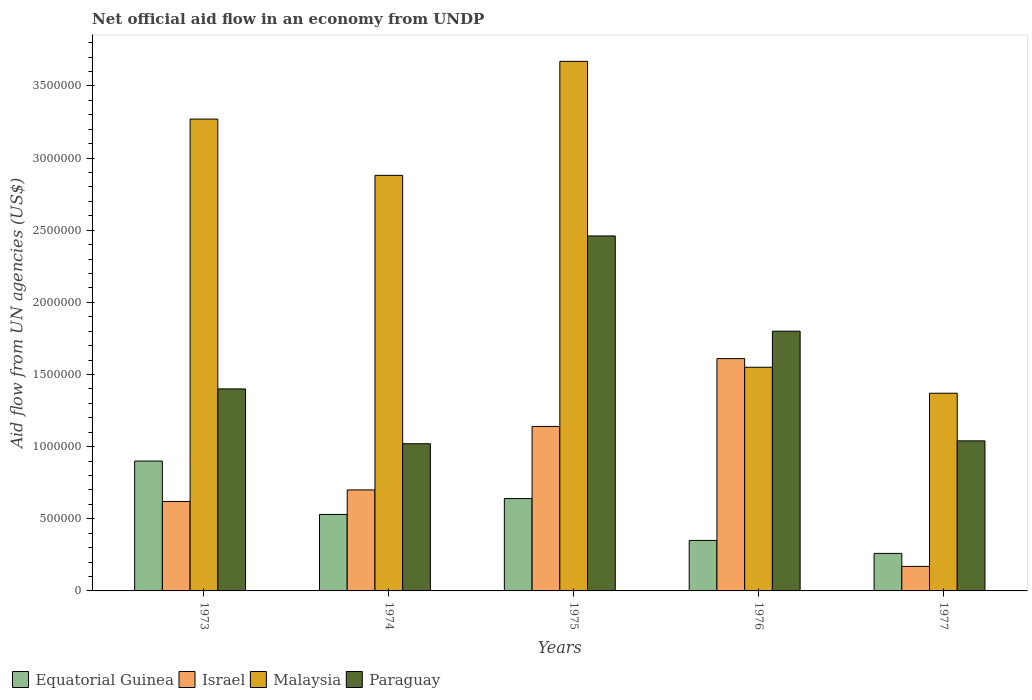How many different coloured bars are there?
Your answer should be very brief. 4. Are the number of bars on each tick of the X-axis equal?
Your answer should be compact. Yes. How many bars are there on the 2nd tick from the left?
Keep it short and to the point. 4. What is the label of the 4th group of bars from the left?
Your answer should be very brief. 1976. In how many cases, is the number of bars for a given year not equal to the number of legend labels?
Your answer should be compact. 0. What is the net official aid flow in Israel in 1976?
Ensure brevity in your answer.  1.61e+06. Across all years, what is the maximum net official aid flow in Israel?
Provide a succinct answer. 1.61e+06. Across all years, what is the minimum net official aid flow in Malaysia?
Your response must be concise. 1.37e+06. In which year was the net official aid flow in Israel maximum?
Give a very brief answer. 1976. In which year was the net official aid flow in Paraguay minimum?
Your response must be concise. 1974. What is the total net official aid flow in Equatorial Guinea in the graph?
Offer a terse response. 2.68e+06. What is the difference between the net official aid flow in Israel in 1977 and the net official aid flow in Malaysia in 1974?
Make the answer very short. -2.71e+06. What is the average net official aid flow in Malaysia per year?
Provide a succinct answer. 2.55e+06. What is the ratio of the net official aid flow in Paraguay in 1974 to that in 1976?
Your answer should be compact. 0.57. Is the difference between the net official aid flow in Israel in 1976 and 1977 greater than the difference between the net official aid flow in Equatorial Guinea in 1976 and 1977?
Make the answer very short. Yes. What is the difference between the highest and the second highest net official aid flow in Paraguay?
Give a very brief answer. 6.60e+05. What is the difference between the highest and the lowest net official aid flow in Malaysia?
Provide a succinct answer. 2.30e+06. In how many years, is the net official aid flow in Paraguay greater than the average net official aid flow in Paraguay taken over all years?
Ensure brevity in your answer.  2. Is the sum of the net official aid flow in Israel in 1975 and 1976 greater than the maximum net official aid flow in Equatorial Guinea across all years?
Your answer should be very brief. Yes. Is it the case that in every year, the sum of the net official aid flow in Israel and net official aid flow in Equatorial Guinea is greater than the sum of net official aid flow in Malaysia and net official aid flow in Paraguay?
Offer a very short reply. No. What does the 1st bar from the left in 1977 represents?
Offer a very short reply. Equatorial Guinea. What does the 1st bar from the right in 1973 represents?
Give a very brief answer. Paraguay. How many bars are there?
Give a very brief answer. 20. Are all the bars in the graph horizontal?
Keep it short and to the point. No. How many years are there in the graph?
Ensure brevity in your answer.  5. Are the values on the major ticks of Y-axis written in scientific E-notation?
Ensure brevity in your answer.  No. Does the graph contain any zero values?
Your answer should be compact. No. How many legend labels are there?
Provide a short and direct response. 4. What is the title of the graph?
Give a very brief answer. Net official aid flow in an economy from UNDP. Does "Turkey" appear as one of the legend labels in the graph?
Ensure brevity in your answer.  No. What is the label or title of the Y-axis?
Provide a succinct answer. Aid flow from UN agencies (US$). What is the Aid flow from UN agencies (US$) of Equatorial Guinea in 1973?
Give a very brief answer. 9.00e+05. What is the Aid flow from UN agencies (US$) in Israel in 1973?
Your response must be concise. 6.20e+05. What is the Aid flow from UN agencies (US$) in Malaysia in 1973?
Offer a very short reply. 3.27e+06. What is the Aid flow from UN agencies (US$) in Paraguay in 1973?
Keep it short and to the point. 1.40e+06. What is the Aid flow from UN agencies (US$) of Equatorial Guinea in 1974?
Ensure brevity in your answer.  5.30e+05. What is the Aid flow from UN agencies (US$) of Malaysia in 1974?
Offer a terse response. 2.88e+06. What is the Aid flow from UN agencies (US$) in Paraguay in 1974?
Your answer should be very brief. 1.02e+06. What is the Aid flow from UN agencies (US$) in Equatorial Guinea in 1975?
Make the answer very short. 6.40e+05. What is the Aid flow from UN agencies (US$) of Israel in 1975?
Your response must be concise. 1.14e+06. What is the Aid flow from UN agencies (US$) in Malaysia in 1975?
Give a very brief answer. 3.67e+06. What is the Aid flow from UN agencies (US$) in Paraguay in 1975?
Offer a very short reply. 2.46e+06. What is the Aid flow from UN agencies (US$) of Israel in 1976?
Make the answer very short. 1.61e+06. What is the Aid flow from UN agencies (US$) of Malaysia in 1976?
Keep it short and to the point. 1.55e+06. What is the Aid flow from UN agencies (US$) of Paraguay in 1976?
Provide a short and direct response. 1.80e+06. What is the Aid flow from UN agencies (US$) of Israel in 1977?
Your answer should be compact. 1.70e+05. What is the Aid flow from UN agencies (US$) in Malaysia in 1977?
Provide a succinct answer. 1.37e+06. What is the Aid flow from UN agencies (US$) in Paraguay in 1977?
Your answer should be compact. 1.04e+06. Across all years, what is the maximum Aid flow from UN agencies (US$) in Israel?
Make the answer very short. 1.61e+06. Across all years, what is the maximum Aid flow from UN agencies (US$) in Malaysia?
Your response must be concise. 3.67e+06. Across all years, what is the maximum Aid flow from UN agencies (US$) in Paraguay?
Make the answer very short. 2.46e+06. Across all years, what is the minimum Aid flow from UN agencies (US$) in Israel?
Give a very brief answer. 1.70e+05. Across all years, what is the minimum Aid flow from UN agencies (US$) in Malaysia?
Your answer should be compact. 1.37e+06. Across all years, what is the minimum Aid flow from UN agencies (US$) in Paraguay?
Your answer should be very brief. 1.02e+06. What is the total Aid flow from UN agencies (US$) of Equatorial Guinea in the graph?
Offer a very short reply. 2.68e+06. What is the total Aid flow from UN agencies (US$) in Israel in the graph?
Offer a very short reply. 4.24e+06. What is the total Aid flow from UN agencies (US$) of Malaysia in the graph?
Your response must be concise. 1.27e+07. What is the total Aid flow from UN agencies (US$) of Paraguay in the graph?
Your answer should be very brief. 7.72e+06. What is the difference between the Aid flow from UN agencies (US$) in Equatorial Guinea in 1973 and that in 1974?
Ensure brevity in your answer.  3.70e+05. What is the difference between the Aid flow from UN agencies (US$) in Equatorial Guinea in 1973 and that in 1975?
Offer a terse response. 2.60e+05. What is the difference between the Aid flow from UN agencies (US$) in Israel in 1973 and that in 1975?
Keep it short and to the point. -5.20e+05. What is the difference between the Aid flow from UN agencies (US$) of Malaysia in 1973 and that in 1975?
Provide a short and direct response. -4.00e+05. What is the difference between the Aid flow from UN agencies (US$) of Paraguay in 1973 and that in 1975?
Keep it short and to the point. -1.06e+06. What is the difference between the Aid flow from UN agencies (US$) in Israel in 1973 and that in 1976?
Keep it short and to the point. -9.90e+05. What is the difference between the Aid flow from UN agencies (US$) in Malaysia in 1973 and that in 1976?
Offer a very short reply. 1.72e+06. What is the difference between the Aid flow from UN agencies (US$) of Paraguay in 1973 and that in 1976?
Your answer should be very brief. -4.00e+05. What is the difference between the Aid flow from UN agencies (US$) of Equatorial Guinea in 1973 and that in 1977?
Your answer should be compact. 6.40e+05. What is the difference between the Aid flow from UN agencies (US$) in Israel in 1973 and that in 1977?
Offer a terse response. 4.50e+05. What is the difference between the Aid flow from UN agencies (US$) of Malaysia in 1973 and that in 1977?
Provide a short and direct response. 1.90e+06. What is the difference between the Aid flow from UN agencies (US$) in Paraguay in 1973 and that in 1977?
Provide a succinct answer. 3.60e+05. What is the difference between the Aid flow from UN agencies (US$) of Equatorial Guinea in 1974 and that in 1975?
Give a very brief answer. -1.10e+05. What is the difference between the Aid flow from UN agencies (US$) of Israel in 1974 and that in 1975?
Your answer should be compact. -4.40e+05. What is the difference between the Aid flow from UN agencies (US$) in Malaysia in 1974 and that in 1975?
Provide a short and direct response. -7.90e+05. What is the difference between the Aid flow from UN agencies (US$) in Paraguay in 1974 and that in 1975?
Your answer should be very brief. -1.44e+06. What is the difference between the Aid flow from UN agencies (US$) of Equatorial Guinea in 1974 and that in 1976?
Provide a succinct answer. 1.80e+05. What is the difference between the Aid flow from UN agencies (US$) of Israel in 1974 and that in 1976?
Provide a short and direct response. -9.10e+05. What is the difference between the Aid flow from UN agencies (US$) of Malaysia in 1974 and that in 1976?
Your answer should be compact. 1.33e+06. What is the difference between the Aid flow from UN agencies (US$) in Paraguay in 1974 and that in 1976?
Ensure brevity in your answer.  -7.80e+05. What is the difference between the Aid flow from UN agencies (US$) of Equatorial Guinea in 1974 and that in 1977?
Provide a short and direct response. 2.70e+05. What is the difference between the Aid flow from UN agencies (US$) of Israel in 1974 and that in 1977?
Offer a terse response. 5.30e+05. What is the difference between the Aid flow from UN agencies (US$) in Malaysia in 1974 and that in 1977?
Your answer should be very brief. 1.51e+06. What is the difference between the Aid flow from UN agencies (US$) in Equatorial Guinea in 1975 and that in 1976?
Your answer should be very brief. 2.90e+05. What is the difference between the Aid flow from UN agencies (US$) of Israel in 1975 and that in 1976?
Keep it short and to the point. -4.70e+05. What is the difference between the Aid flow from UN agencies (US$) of Malaysia in 1975 and that in 1976?
Your answer should be very brief. 2.12e+06. What is the difference between the Aid flow from UN agencies (US$) in Israel in 1975 and that in 1977?
Ensure brevity in your answer.  9.70e+05. What is the difference between the Aid flow from UN agencies (US$) in Malaysia in 1975 and that in 1977?
Give a very brief answer. 2.30e+06. What is the difference between the Aid flow from UN agencies (US$) of Paraguay in 1975 and that in 1977?
Make the answer very short. 1.42e+06. What is the difference between the Aid flow from UN agencies (US$) of Israel in 1976 and that in 1977?
Offer a very short reply. 1.44e+06. What is the difference between the Aid flow from UN agencies (US$) in Malaysia in 1976 and that in 1977?
Offer a terse response. 1.80e+05. What is the difference between the Aid flow from UN agencies (US$) in Paraguay in 1976 and that in 1977?
Give a very brief answer. 7.60e+05. What is the difference between the Aid flow from UN agencies (US$) of Equatorial Guinea in 1973 and the Aid flow from UN agencies (US$) of Malaysia in 1974?
Your answer should be very brief. -1.98e+06. What is the difference between the Aid flow from UN agencies (US$) in Israel in 1973 and the Aid flow from UN agencies (US$) in Malaysia in 1974?
Provide a short and direct response. -2.26e+06. What is the difference between the Aid flow from UN agencies (US$) of Israel in 1973 and the Aid flow from UN agencies (US$) of Paraguay in 1974?
Offer a very short reply. -4.00e+05. What is the difference between the Aid flow from UN agencies (US$) of Malaysia in 1973 and the Aid flow from UN agencies (US$) of Paraguay in 1974?
Provide a short and direct response. 2.25e+06. What is the difference between the Aid flow from UN agencies (US$) in Equatorial Guinea in 1973 and the Aid flow from UN agencies (US$) in Israel in 1975?
Give a very brief answer. -2.40e+05. What is the difference between the Aid flow from UN agencies (US$) in Equatorial Guinea in 1973 and the Aid flow from UN agencies (US$) in Malaysia in 1975?
Keep it short and to the point. -2.77e+06. What is the difference between the Aid flow from UN agencies (US$) of Equatorial Guinea in 1973 and the Aid flow from UN agencies (US$) of Paraguay in 1975?
Your answer should be compact. -1.56e+06. What is the difference between the Aid flow from UN agencies (US$) in Israel in 1973 and the Aid flow from UN agencies (US$) in Malaysia in 1975?
Your answer should be very brief. -3.05e+06. What is the difference between the Aid flow from UN agencies (US$) in Israel in 1973 and the Aid flow from UN agencies (US$) in Paraguay in 1975?
Your answer should be compact. -1.84e+06. What is the difference between the Aid flow from UN agencies (US$) of Malaysia in 1973 and the Aid flow from UN agencies (US$) of Paraguay in 1975?
Offer a very short reply. 8.10e+05. What is the difference between the Aid flow from UN agencies (US$) in Equatorial Guinea in 1973 and the Aid flow from UN agencies (US$) in Israel in 1976?
Make the answer very short. -7.10e+05. What is the difference between the Aid flow from UN agencies (US$) of Equatorial Guinea in 1973 and the Aid flow from UN agencies (US$) of Malaysia in 1976?
Offer a terse response. -6.50e+05. What is the difference between the Aid flow from UN agencies (US$) of Equatorial Guinea in 1973 and the Aid flow from UN agencies (US$) of Paraguay in 1976?
Your answer should be very brief. -9.00e+05. What is the difference between the Aid flow from UN agencies (US$) of Israel in 1973 and the Aid flow from UN agencies (US$) of Malaysia in 1976?
Offer a very short reply. -9.30e+05. What is the difference between the Aid flow from UN agencies (US$) in Israel in 1973 and the Aid flow from UN agencies (US$) in Paraguay in 1976?
Offer a terse response. -1.18e+06. What is the difference between the Aid flow from UN agencies (US$) of Malaysia in 1973 and the Aid flow from UN agencies (US$) of Paraguay in 1976?
Provide a succinct answer. 1.47e+06. What is the difference between the Aid flow from UN agencies (US$) in Equatorial Guinea in 1973 and the Aid flow from UN agencies (US$) in Israel in 1977?
Offer a very short reply. 7.30e+05. What is the difference between the Aid flow from UN agencies (US$) of Equatorial Guinea in 1973 and the Aid flow from UN agencies (US$) of Malaysia in 1977?
Offer a terse response. -4.70e+05. What is the difference between the Aid flow from UN agencies (US$) of Equatorial Guinea in 1973 and the Aid flow from UN agencies (US$) of Paraguay in 1977?
Provide a succinct answer. -1.40e+05. What is the difference between the Aid flow from UN agencies (US$) of Israel in 1973 and the Aid flow from UN agencies (US$) of Malaysia in 1977?
Your answer should be very brief. -7.50e+05. What is the difference between the Aid flow from UN agencies (US$) of Israel in 1973 and the Aid flow from UN agencies (US$) of Paraguay in 1977?
Your answer should be very brief. -4.20e+05. What is the difference between the Aid flow from UN agencies (US$) in Malaysia in 1973 and the Aid flow from UN agencies (US$) in Paraguay in 1977?
Provide a short and direct response. 2.23e+06. What is the difference between the Aid flow from UN agencies (US$) of Equatorial Guinea in 1974 and the Aid flow from UN agencies (US$) of Israel in 1975?
Keep it short and to the point. -6.10e+05. What is the difference between the Aid flow from UN agencies (US$) in Equatorial Guinea in 1974 and the Aid flow from UN agencies (US$) in Malaysia in 1975?
Your answer should be compact. -3.14e+06. What is the difference between the Aid flow from UN agencies (US$) of Equatorial Guinea in 1974 and the Aid flow from UN agencies (US$) of Paraguay in 1975?
Offer a terse response. -1.93e+06. What is the difference between the Aid flow from UN agencies (US$) of Israel in 1974 and the Aid flow from UN agencies (US$) of Malaysia in 1975?
Your answer should be very brief. -2.97e+06. What is the difference between the Aid flow from UN agencies (US$) of Israel in 1974 and the Aid flow from UN agencies (US$) of Paraguay in 1975?
Ensure brevity in your answer.  -1.76e+06. What is the difference between the Aid flow from UN agencies (US$) in Equatorial Guinea in 1974 and the Aid flow from UN agencies (US$) in Israel in 1976?
Provide a short and direct response. -1.08e+06. What is the difference between the Aid flow from UN agencies (US$) in Equatorial Guinea in 1974 and the Aid flow from UN agencies (US$) in Malaysia in 1976?
Give a very brief answer. -1.02e+06. What is the difference between the Aid flow from UN agencies (US$) in Equatorial Guinea in 1974 and the Aid flow from UN agencies (US$) in Paraguay in 1976?
Your answer should be very brief. -1.27e+06. What is the difference between the Aid flow from UN agencies (US$) of Israel in 1974 and the Aid flow from UN agencies (US$) of Malaysia in 1976?
Provide a succinct answer. -8.50e+05. What is the difference between the Aid flow from UN agencies (US$) in Israel in 1974 and the Aid flow from UN agencies (US$) in Paraguay in 1976?
Give a very brief answer. -1.10e+06. What is the difference between the Aid flow from UN agencies (US$) in Malaysia in 1974 and the Aid flow from UN agencies (US$) in Paraguay in 1976?
Your answer should be compact. 1.08e+06. What is the difference between the Aid flow from UN agencies (US$) in Equatorial Guinea in 1974 and the Aid flow from UN agencies (US$) in Malaysia in 1977?
Keep it short and to the point. -8.40e+05. What is the difference between the Aid flow from UN agencies (US$) in Equatorial Guinea in 1974 and the Aid flow from UN agencies (US$) in Paraguay in 1977?
Your answer should be compact. -5.10e+05. What is the difference between the Aid flow from UN agencies (US$) of Israel in 1974 and the Aid flow from UN agencies (US$) of Malaysia in 1977?
Provide a succinct answer. -6.70e+05. What is the difference between the Aid flow from UN agencies (US$) of Malaysia in 1974 and the Aid flow from UN agencies (US$) of Paraguay in 1977?
Offer a very short reply. 1.84e+06. What is the difference between the Aid flow from UN agencies (US$) in Equatorial Guinea in 1975 and the Aid flow from UN agencies (US$) in Israel in 1976?
Ensure brevity in your answer.  -9.70e+05. What is the difference between the Aid flow from UN agencies (US$) in Equatorial Guinea in 1975 and the Aid flow from UN agencies (US$) in Malaysia in 1976?
Your answer should be very brief. -9.10e+05. What is the difference between the Aid flow from UN agencies (US$) in Equatorial Guinea in 1975 and the Aid flow from UN agencies (US$) in Paraguay in 1976?
Your answer should be very brief. -1.16e+06. What is the difference between the Aid flow from UN agencies (US$) in Israel in 1975 and the Aid flow from UN agencies (US$) in Malaysia in 1976?
Your answer should be compact. -4.10e+05. What is the difference between the Aid flow from UN agencies (US$) of Israel in 1975 and the Aid flow from UN agencies (US$) of Paraguay in 1976?
Provide a short and direct response. -6.60e+05. What is the difference between the Aid flow from UN agencies (US$) of Malaysia in 1975 and the Aid flow from UN agencies (US$) of Paraguay in 1976?
Offer a very short reply. 1.87e+06. What is the difference between the Aid flow from UN agencies (US$) of Equatorial Guinea in 1975 and the Aid flow from UN agencies (US$) of Israel in 1977?
Ensure brevity in your answer.  4.70e+05. What is the difference between the Aid flow from UN agencies (US$) in Equatorial Guinea in 1975 and the Aid flow from UN agencies (US$) in Malaysia in 1977?
Give a very brief answer. -7.30e+05. What is the difference between the Aid flow from UN agencies (US$) of Equatorial Guinea in 1975 and the Aid flow from UN agencies (US$) of Paraguay in 1977?
Ensure brevity in your answer.  -4.00e+05. What is the difference between the Aid flow from UN agencies (US$) in Israel in 1975 and the Aid flow from UN agencies (US$) in Malaysia in 1977?
Offer a very short reply. -2.30e+05. What is the difference between the Aid flow from UN agencies (US$) in Malaysia in 1975 and the Aid flow from UN agencies (US$) in Paraguay in 1977?
Your answer should be compact. 2.63e+06. What is the difference between the Aid flow from UN agencies (US$) of Equatorial Guinea in 1976 and the Aid flow from UN agencies (US$) of Malaysia in 1977?
Make the answer very short. -1.02e+06. What is the difference between the Aid flow from UN agencies (US$) of Equatorial Guinea in 1976 and the Aid flow from UN agencies (US$) of Paraguay in 1977?
Your answer should be compact. -6.90e+05. What is the difference between the Aid flow from UN agencies (US$) of Israel in 1976 and the Aid flow from UN agencies (US$) of Paraguay in 1977?
Provide a short and direct response. 5.70e+05. What is the difference between the Aid flow from UN agencies (US$) in Malaysia in 1976 and the Aid flow from UN agencies (US$) in Paraguay in 1977?
Offer a terse response. 5.10e+05. What is the average Aid flow from UN agencies (US$) in Equatorial Guinea per year?
Ensure brevity in your answer.  5.36e+05. What is the average Aid flow from UN agencies (US$) of Israel per year?
Provide a succinct answer. 8.48e+05. What is the average Aid flow from UN agencies (US$) of Malaysia per year?
Make the answer very short. 2.55e+06. What is the average Aid flow from UN agencies (US$) in Paraguay per year?
Offer a very short reply. 1.54e+06. In the year 1973, what is the difference between the Aid flow from UN agencies (US$) of Equatorial Guinea and Aid flow from UN agencies (US$) of Malaysia?
Offer a very short reply. -2.37e+06. In the year 1973, what is the difference between the Aid flow from UN agencies (US$) in Equatorial Guinea and Aid flow from UN agencies (US$) in Paraguay?
Your response must be concise. -5.00e+05. In the year 1973, what is the difference between the Aid flow from UN agencies (US$) of Israel and Aid flow from UN agencies (US$) of Malaysia?
Give a very brief answer. -2.65e+06. In the year 1973, what is the difference between the Aid flow from UN agencies (US$) of Israel and Aid flow from UN agencies (US$) of Paraguay?
Make the answer very short. -7.80e+05. In the year 1973, what is the difference between the Aid flow from UN agencies (US$) of Malaysia and Aid flow from UN agencies (US$) of Paraguay?
Give a very brief answer. 1.87e+06. In the year 1974, what is the difference between the Aid flow from UN agencies (US$) in Equatorial Guinea and Aid flow from UN agencies (US$) in Israel?
Make the answer very short. -1.70e+05. In the year 1974, what is the difference between the Aid flow from UN agencies (US$) of Equatorial Guinea and Aid flow from UN agencies (US$) of Malaysia?
Keep it short and to the point. -2.35e+06. In the year 1974, what is the difference between the Aid flow from UN agencies (US$) in Equatorial Guinea and Aid flow from UN agencies (US$) in Paraguay?
Your answer should be very brief. -4.90e+05. In the year 1974, what is the difference between the Aid flow from UN agencies (US$) of Israel and Aid flow from UN agencies (US$) of Malaysia?
Your response must be concise. -2.18e+06. In the year 1974, what is the difference between the Aid flow from UN agencies (US$) of Israel and Aid flow from UN agencies (US$) of Paraguay?
Provide a succinct answer. -3.20e+05. In the year 1974, what is the difference between the Aid flow from UN agencies (US$) in Malaysia and Aid flow from UN agencies (US$) in Paraguay?
Make the answer very short. 1.86e+06. In the year 1975, what is the difference between the Aid flow from UN agencies (US$) in Equatorial Guinea and Aid flow from UN agencies (US$) in Israel?
Provide a short and direct response. -5.00e+05. In the year 1975, what is the difference between the Aid flow from UN agencies (US$) of Equatorial Guinea and Aid flow from UN agencies (US$) of Malaysia?
Give a very brief answer. -3.03e+06. In the year 1975, what is the difference between the Aid flow from UN agencies (US$) in Equatorial Guinea and Aid flow from UN agencies (US$) in Paraguay?
Your answer should be very brief. -1.82e+06. In the year 1975, what is the difference between the Aid flow from UN agencies (US$) of Israel and Aid flow from UN agencies (US$) of Malaysia?
Offer a terse response. -2.53e+06. In the year 1975, what is the difference between the Aid flow from UN agencies (US$) in Israel and Aid flow from UN agencies (US$) in Paraguay?
Your answer should be very brief. -1.32e+06. In the year 1975, what is the difference between the Aid flow from UN agencies (US$) in Malaysia and Aid flow from UN agencies (US$) in Paraguay?
Offer a terse response. 1.21e+06. In the year 1976, what is the difference between the Aid flow from UN agencies (US$) in Equatorial Guinea and Aid flow from UN agencies (US$) in Israel?
Provide a succinct answer. -1.26e+06. In the year 1976, what is the difference between the Aid flow from UN agencies (US$) in Equatorial Guinea and Aid flow from UN agencies (US$) in Malaysia?
Ensure brevity in your answer.  -1.20e+06. In the year 1976, what is the difference between the Aid flow from UN agencies (US$) of Equatorial Guinea and Aid flow from UN agencies (US$) of Paraguay?
Your answer should be compact. -1.45e+06. In the year 1976, what is the difference between the Aid flow from UN agencies (US$) in Israel and Aid flow from UN agencies (US$) in Malaysia?
Give a very brief answer. 6.00e+04. In the year 1976, what is the difference between the Aid flow from UN agencies (US$) of Malaysia and Aid flow from UN agencies (US$) of Paraguay?
Offer a terse response. -2.50e+05. In the year 1977, what is the difference between the Aid flow from UN agencies (US$) in Equatorial Guinea and Aid flow from UN agencies (US$) in Israel?
Provide a short and direct response. 9.00e+04. In the year 1977, what is the difference between the Aid flow from UN agencies (US$) in Equatorial Guinea and Aid flow from UN agencies (US$) in Malaysia?
Keep it short and to the point. -1.11e+06. In the year 1977, what is the difference between the Aid flow from UN agencies (US$) in Equatorial Guinea and Aid flow from UN agencies (US$) in Paraguay?
Your response must be concise. -7.80e+05. In the year 1977, what is the difference between the Aid flow from UN agencies (US$) in Israel and Aid flow from UN agencies (US$) in Malaysia?
Your answer should be very brief. -1.20e+06. In the year 1977, what is the difference between the Aid flow from UN agencies (US$) in Israel and Aid flow from UN agencies (US$) in Paraguay?
Your response must be concise. -8.70e+05. What is the ratio of the Aid flow from UN agencies (US$) of Equatorial Guinea in 1973 to that in 1974?
Give a very brief answer. 1.7. What is the ratio of the Aid flow from UN agencies (US$) in Israel in 1973 to that in 1974?
Your answer should be very brief. 0.89. What is the ratio of the Aid flow from UN agencies (US$) in Malaysia in 1973 to that in 1974?
Offer a very short reply. 1.14. What is the ratio of the Aid flow from UN agencies (US$) in Paraguay in 1973 to that in 1974?
Offer a very short reply. 1.37. What is the ratio of the Aid flow from UN agencies (US$) in Equatorial Guinea in 1973 to that in 1975?
Provide a short and direct response. 1.41. What is the ratio of the Aid flow from UN agencies (US$) of Israel in 1973 to that in 1975?
Provide a short and direct response. 0.54. What is the ratio of the Aid flow from UN agencies (US$) in Malaysia in 1973 to that in 1975?
Your answer should be compact. 0.89. What is the ratio of the Aid flow from UN agencies (US$) in Paraguay in 1973 to that in 1975?
Your answer should be compact. 0.57. What is the ratio of the Aid flow from UN agencies (US$) in Equatorial Guinea in 1973 to that in 1976?
Your response must be concise. 2.57. What is the ratio of the Aid flow from UN agencies (US$) in Israel in 1973 to that in 1976?
Make the answer very short. 0.39. What is the ratio of the Aid flow from UN agencies (US$) of Malaysia in 1973 to that in 1976?
Your response must be concise. 2.11. What is the ratio of the Aid flow from UN agencies (US$) in Paraguay in 1973 to that in 1976?
Provide a short and direct response. 0.78. What is the ratio of the Aid flow from UN agencies (US$) of Equatorial Guinea in 1973 to that in 1977?
Your response must be concise. 3.46. What is the ratio of the Aid flow from UN agencies (US$) in Israel in 1973 to that in 1977?
Provide a short and direct response. 3.65. What is the ratio of the Aid flow from UN agencies (US$) in Malaysia in 1973 to that in 1977?
Provide a short and direct response. 2.39. What is the ratio of the Aid flow from UN agencies (US$) in Paraguay in 1973 to that in 1977?
Your answer should be compact. 1.35. What is the ratio of the Aid flow from UN agencies (US$) of Equatorial Guinea in 1974 to that in 1975?
Keep it short and to the point. 0.83. What is the ratio of the Aid flow from UN agencies (US$) in Israel in 1974 to that in 1975?
Offer a very short reply. 0.61. What is the ratio of the Aid flow from UN agencies (US$) of Malaysia in 1974 to that in 1975?
Provide a succinct answer. 0.78. What is the ratio of the Aid flow from UN agencies (US$) of Paraguay in 1974 to that in 1975?
Provide a succinct answer. 0.41. What is the ratio of the Aid flow from UN agencies (US$) of Equatorial Guinea in 1974 to that in 1976?
Make the answer very short. 1.51. What is the ratio of the Aid flow from UN agencies (US$) in Israel in 1974 to that in 1976?
Offer a terse response. 0.43. What is the ratio of the Aid flow from UN agencies (US$) of Malaysia in 1974 to that in 1976?
Your answer should be compact. 1.86. What is the ratio of the Aid flow from UN agencies (US$) of Paraguay in 1974 to that in 1976?
Your answer should be compact. 0.57. What is the ratio of the Aid flow from UN agencies (US$) of Equatorial Guinea in 1974 to that in 1977?
Give a very brief answer. 2.04. What is the ratio of the Aid flow from UN agencies (US$) of Israel in 1974 to that in 1977?
Your response must be concise. 4.12. What is the ratio of the Aid flow from UN agencies (US$) of Malaysia in 1974 to that in 1977?
Provide a succinct answer. 2.1. What is the ratio of the Aid flow from UN agencies (US$) of Paraguay in 1974 to that in 1977?
Make the answer very short. 0.98. What is the ratio of the Aid flow from UN agencies (US$) of Equatorial Guinea in 1975 to that in 1976?
Give a very brief answer. 1.83. What is the ratio of the Aid flow from UN agencies (US$) in Israel in 1975 to that in 1976?
Give a very brief answer. 0.71. What is the ratio of the Aid flow from UN agencies (US$) in Malaysia in 1975 to that in 1976?
Your answer should be very brief. 2.37. What is the ratio of the Aid flow from UN agencies (US$) in Paraguay in 1975 to that in 1976?
Offer a very short reply. 1.37. What is the ratio of the Aid flow from UN agencies (US$) of Equatorial Guinea in 1975 to that in 1977?
Your response must be concise. 2.46. What is the ratio of the Aid flow from UN agencies (US$) of Israel in 1975 to that in 1977?
Your response must be concise. 6.71. What is the ratio of the Aid flow from UN agencies (US$) of Malaysia in 1975 to that in 1977?
Your answer should be compact. 2.68. What is the ratio of the Aid flow from UN agencies (US$) of Paraguay in 1975 to that in 1977?
Provide a succinct answer. 2.37. What is the ratio of the Aid flow from UN agencies (US$) in Equatorial Guinea in 1976 to that in 1977?
Make the answer very short. 1.35. What is the ratio of the Aid flow from UN agencies (US$) in Israel in 1976 to that in 1977?
Ensure brevity in your answer.  9.47. What is the ratio of the Aid flow from UN agencies (US$) in Malaysia in 1976 to that in 1977?
Keep it short and to the point. 1.13. What is the ratio of the Aid flow from UN agencies (US$) of Paraguay in 1976 to that in 1977?
Keep it short and to the point. 1.73. What is the difference between the highest and the second highest Aid flow from UN agencies (US$) in Israel?
Give a very brief answer. 4.70e+05. What is the difference between the highest and the second highest Aid flow from UN agencies (US$) in Paraguay?
Your answer should be very brief. 6.60e+05. What is the difference between the highest and the lowest Aid flow from UN agencies (US$) of Equatorial Guinea?
Offer a terse response. 6.40e+05. What is the difference between the highest and the lowest Aid flow from UN agencies (US$) in Israel?
Keep it short and to the point. 1.44e+06. What is the difference between the highest and the lowest Aid flow from UN agencies (US$) in Malaysia?
Provide a succinct answer. 2.30e+06. What is the difference between the highest and the lowest Aid flow from UN agencies (US$) in Paraguay?
Your answer should be compact. 1.44e+06. 